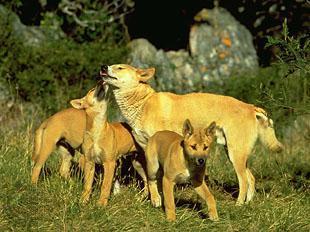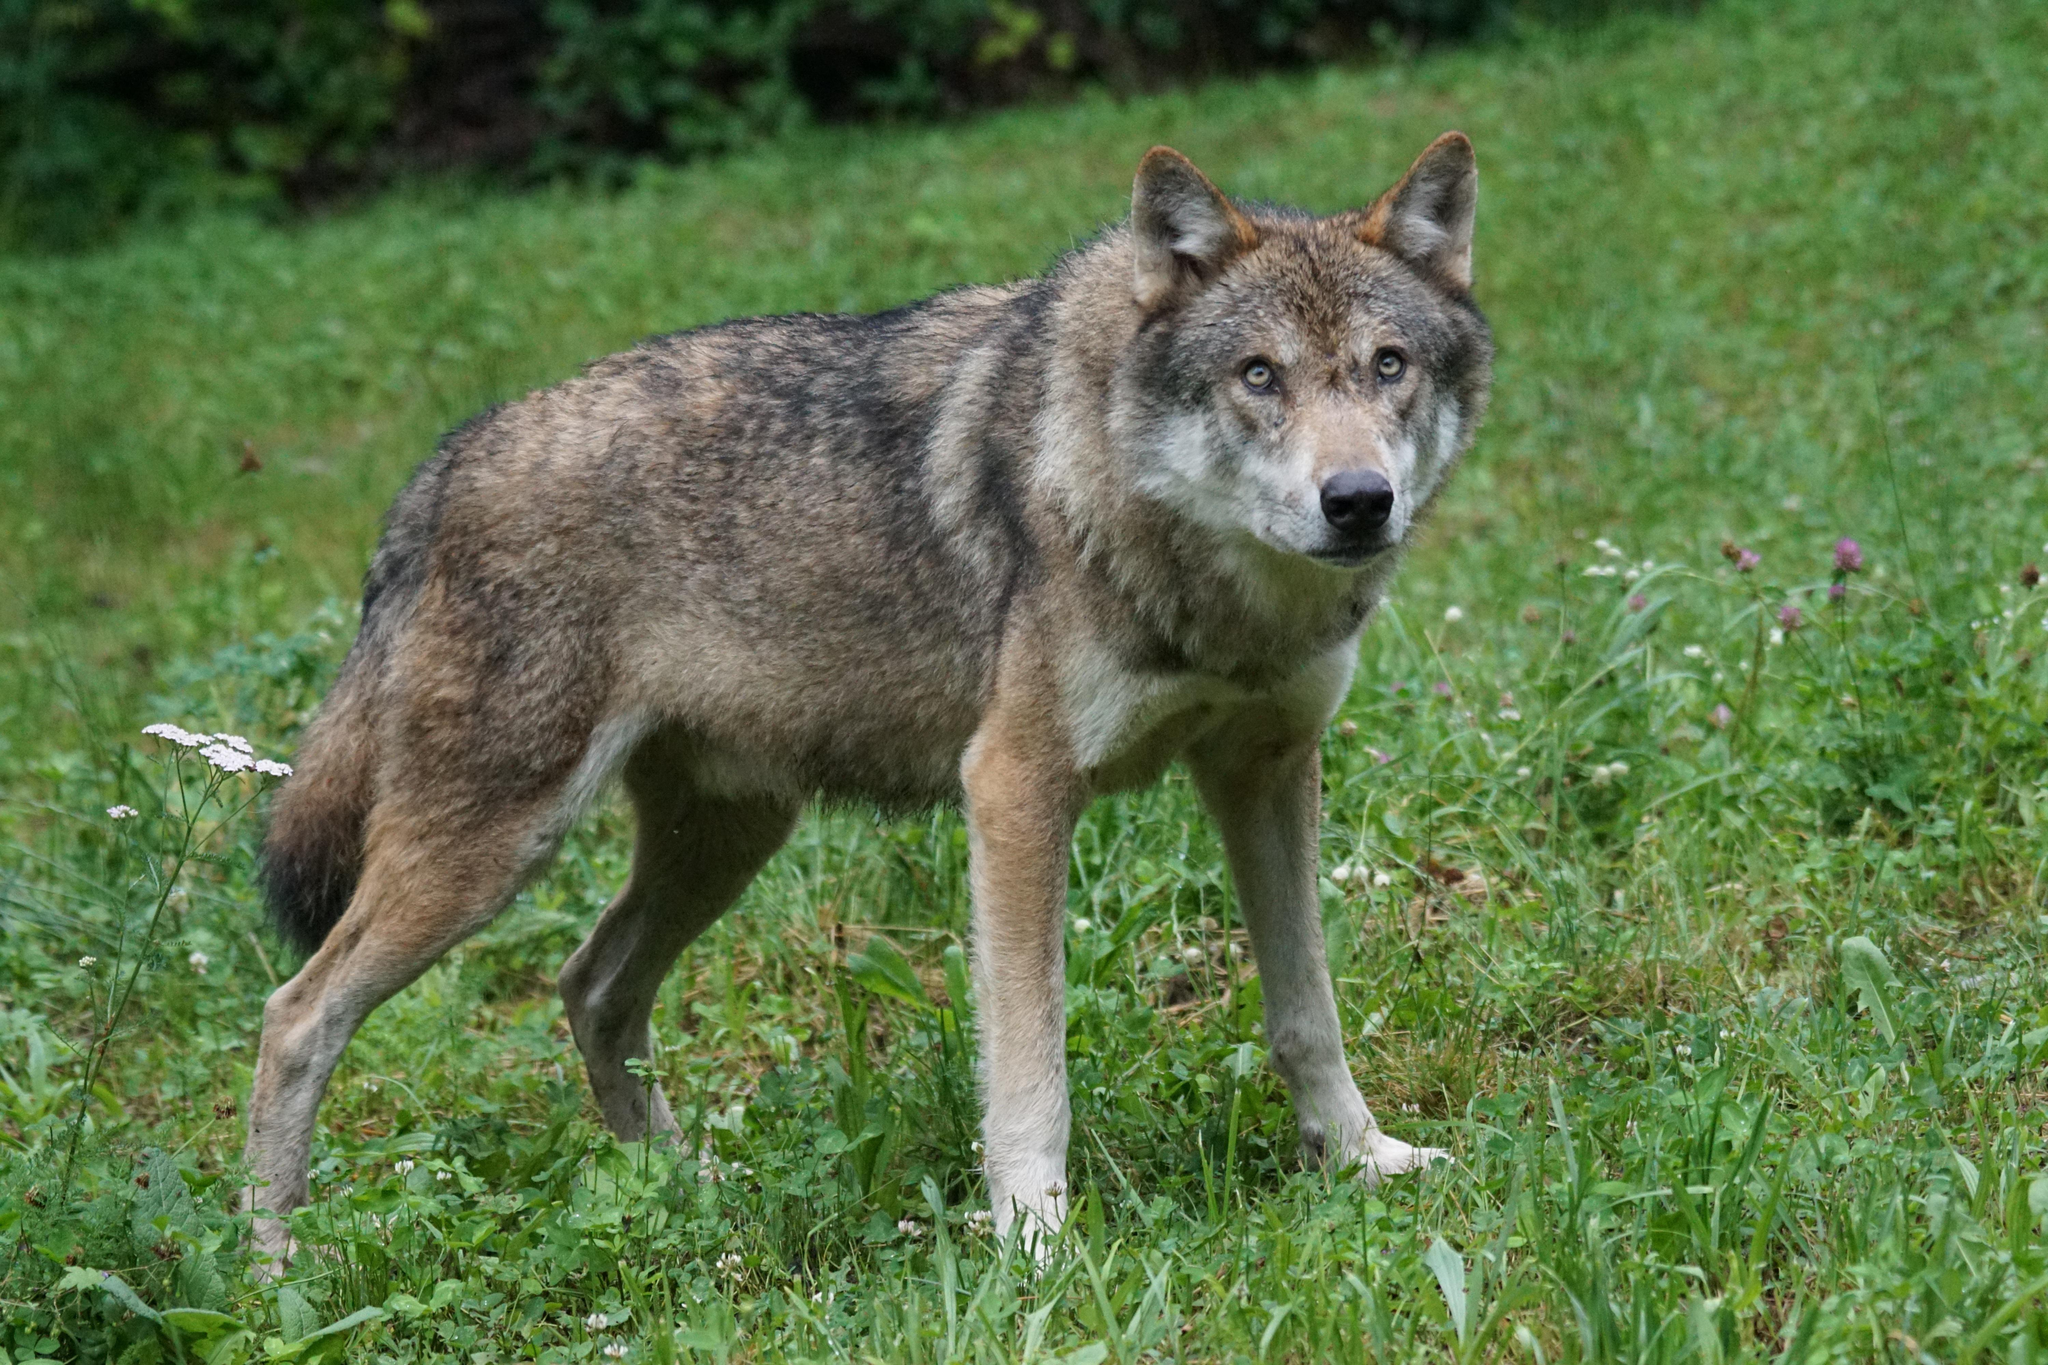The first image is the image on the left, the second image is the image on the right. For the images displayed, is the sentence "There are exactly three canines in the right image." factually correct? Answer yes or no. No. The first image is the image on the left, the second image is the image on the right. For the images shown, is this caption "The left image contains exactly two canines." true? Answer yes or no. No. 